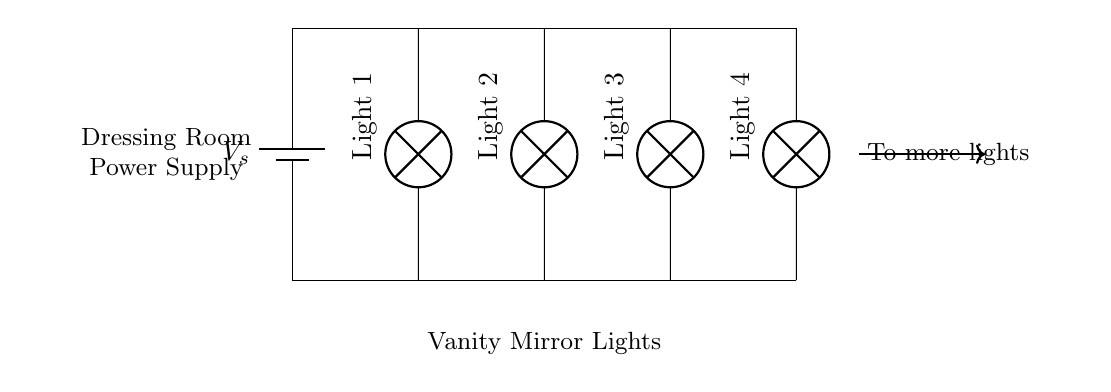What is the voltage source in this circuit? The circuit shows a battery labeled as V_s, which is the part providing the voltage. Therefore, the voltage source is the battery.
Answer: battery V_s How many light bulbs are in this circuit? The circuit diagram depicts four lamps connected in parallel, labeled as Light 1, Light 2, Light 3, and Light 4. Thus, the total number of light bulbs is four.
Answer: four What type of circuit is this? The circuit consists of multiple components connected along separate paths, allowing current to flow through each light independently. This is characteristic of a parallel circuit.
Answer: parallel If one lamp fails, what happens to the others? In parallel circuits, if one component (like a lamp) fails, the other components continue to operate normally since each has its separate path.
Answer: they stay on What is the main function of this circuit? The circuit's primary function is to illuminate vanity mirror lights, as indicated by the labels and arrangement designed for lighting.
Answer: illuminate lights How are the lights connected to the power supply? The lights are connected in parallel, which is demonstrated by their arrangement where each lamp has its direct path to the power supply, allowing equal voltage across all lights.
Answer: in parallel 